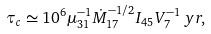<formula> <loc_0><loc_0><loc_500><loc_500>\tau _ { c } \simeq 1 0 ^ { 6 } \mu ^ { - 1 } _ { 3 1 } \dot { M } ^ { - 1 / 2 } _ { 1 7 } I _ { 4 5 } V ^ { - 1 } _ { 7 } \, y r ,</formula> 